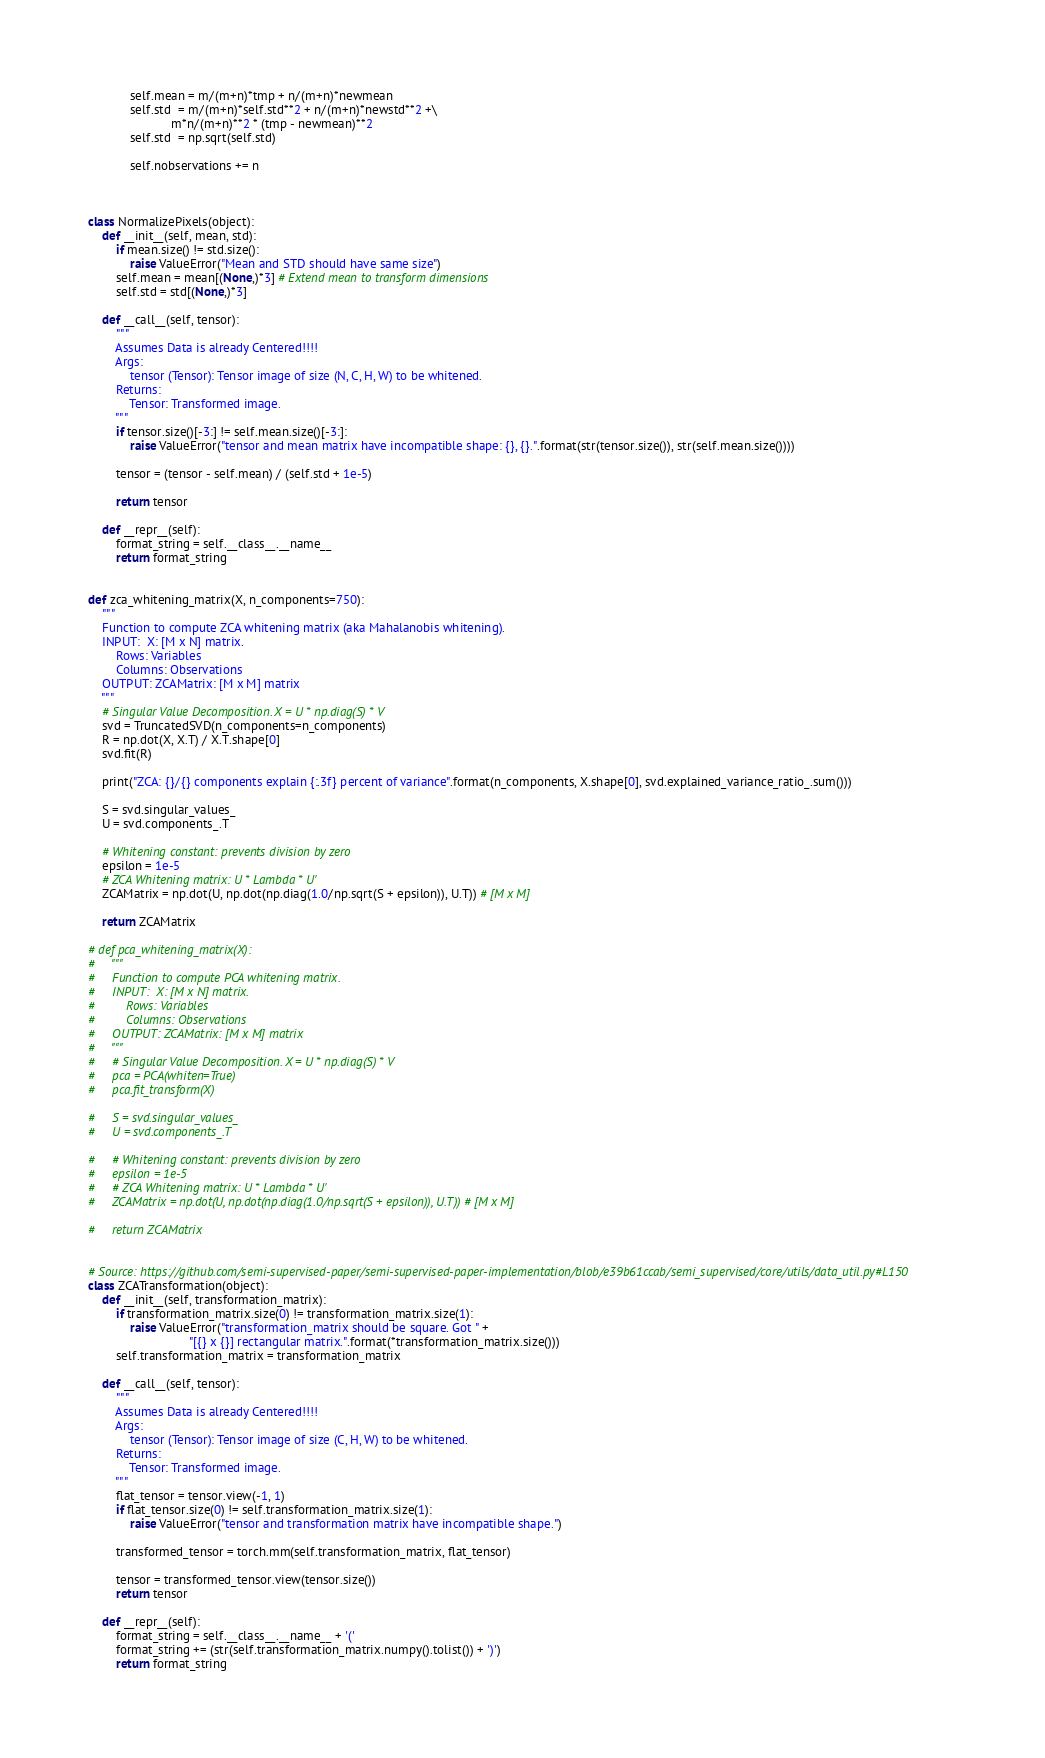<code> <loc_0><loc_0><loc_500><loc_500><_Python_>            self.mean = m/(m+n)*tmp + n/(m+n)*newmean
            self.std  = m/(m+n)*self.std**2 + n/(m+n)*newstd**2 +\
                        m*n/(m+n)**2 * (tmp - newmean)**2
            self.std  = np.sqrt(self.std)

            self.nobservations += n



class NormalizePixels(object):
    def __init__(self, mean, std):
        if mean.size() != std.size():
            raise ValueError("Mean and STD should have same size")
        self.mean = mean[(None,)*3] # Extend mean to transform dimensions
        self.std = std[(None,)*3]

    def __call__(self, tensor):
        """
        Assumes Data is already Centered!!!!
        Args:
            tensor (Tensor): Tensor image of size (N, C, H, W) to be whitened.
        Returns:
            Tensor: Transformed image.
        """
        if tensor.size()[-3:] != self.mean.size()[-3:]:
            raise ValueError("tensor and mean matrix have incompatible shape: {}, {}.".format(str(tensor.size()), str(self.mean.size())))

        tensor = (tensor - self.mean) / (self.std + 1e-5)

        return tensor

    def __repr__(self):
        format_string = self.__class__.__name__ 
        return format_string


def zca_whitening_matrix(X, n_components=750):
    """
    Function to compute ZCA whitening matrix (aka Mahalanobis whitening).
    INPUT:  X: [M x N] matrix.
        Rows: Variables
        Columns: Observations
    OUTPUT: ZCAMatrix: [M x M] matrix
    """
    # Singular Value Decomposition. X = U * np.diag(S) * V
    svd = TruncatedSVD(n_components=n_components)
    R = np.dot(X, X.T) / X.T.shape[0]
    svd.fit(R)

    print("ZCA: {}/{} components explain {:.3f} percent of variance".format(n_components, X.shape[0], svd.explained_variance_ratio_.sum()))

    S = svd.singular_values_
    U = svd.components_.T

    # Whitening constant: prevents division by zero
    epsilon = 1e-5
    # ZCA Whitening matrix: U * Lambda * U'
    ZCAMatrix = np.dot(U, np.dot(np.diag(1.0/np.sqrt(S + epsilon)), U.T)) # [M x M]

    return ZCAMatrix

# def pca_whitening_matrix(X):
#     """
#     Function to compute PCA whitening matrix.
#     INPUT:  X: [M x N] matrix.
#         Rows: Variables
#         Columns: Observations
#     OUTPUT: ZCAMatrix: [M x M] matrix
#     """
#     # Singular Value Decomposition. X = U * np.diag(S) * V
#     pca = PCA(whiten=True)
#     pca.fit_transform(X)

#     S = svd.singular_values_
#     U = svd.components_.T

#     # Whitening constant: prevents division by zero
#     epsilon = 1e-5
#     # ZCA Whitening matrix: U * Lambda * U'
#     ZCAMatrix = np.dot(U, np.dot(np.diag(1.0/np.sqrt(S + epsilon)), U.T)) # [M x M]

#     return ZCAMatrix


# Source: https://github.com/semi-supervised-paper/semi-supervised-paper-implementation/blob/e39b61ccab/semi_supervised/core/utils/data_util.py#L150
class ZCATransformation(object):
    def __init__(self, transformation_matrix):
        if transformation_matrix.size(0) != transformation_matrix.size(1):
            raise ValueError("transformation_matrix should be square. Got " +
                             "[{} x {}] rectangular matrix.".format(*transformation_matrix.size()))
        self.transformation_matrix = transformation_matrix

    def __call__(self, tensor):
        """
        Assumes Data is already Centered!!!!
        Args:
            tensor (Tensor): Tensor image of size (C, H, W) to be whitened.
        Returns:
            Tensor: Transformed image.
        """
        flat_tensor = tensor.view(-1, 1)
        if flat_tensor.size(0) != self.transformation_matrix.size(1):
            raise ValueError("tensor and transformation matrix have incompatible shape.")

        transformed_tensor = torch.mm(self.transformation_matrix, flat_tensor)

        tensor = transformed_tensor.view(tensor.size())
        return tensor

    def __repr__(self):
        format_string = self.__class__.__name__ + '('
        format_string += (str(self.transformation_matrix.numpy().tolist()) + ')')
        return format_string
</code> 